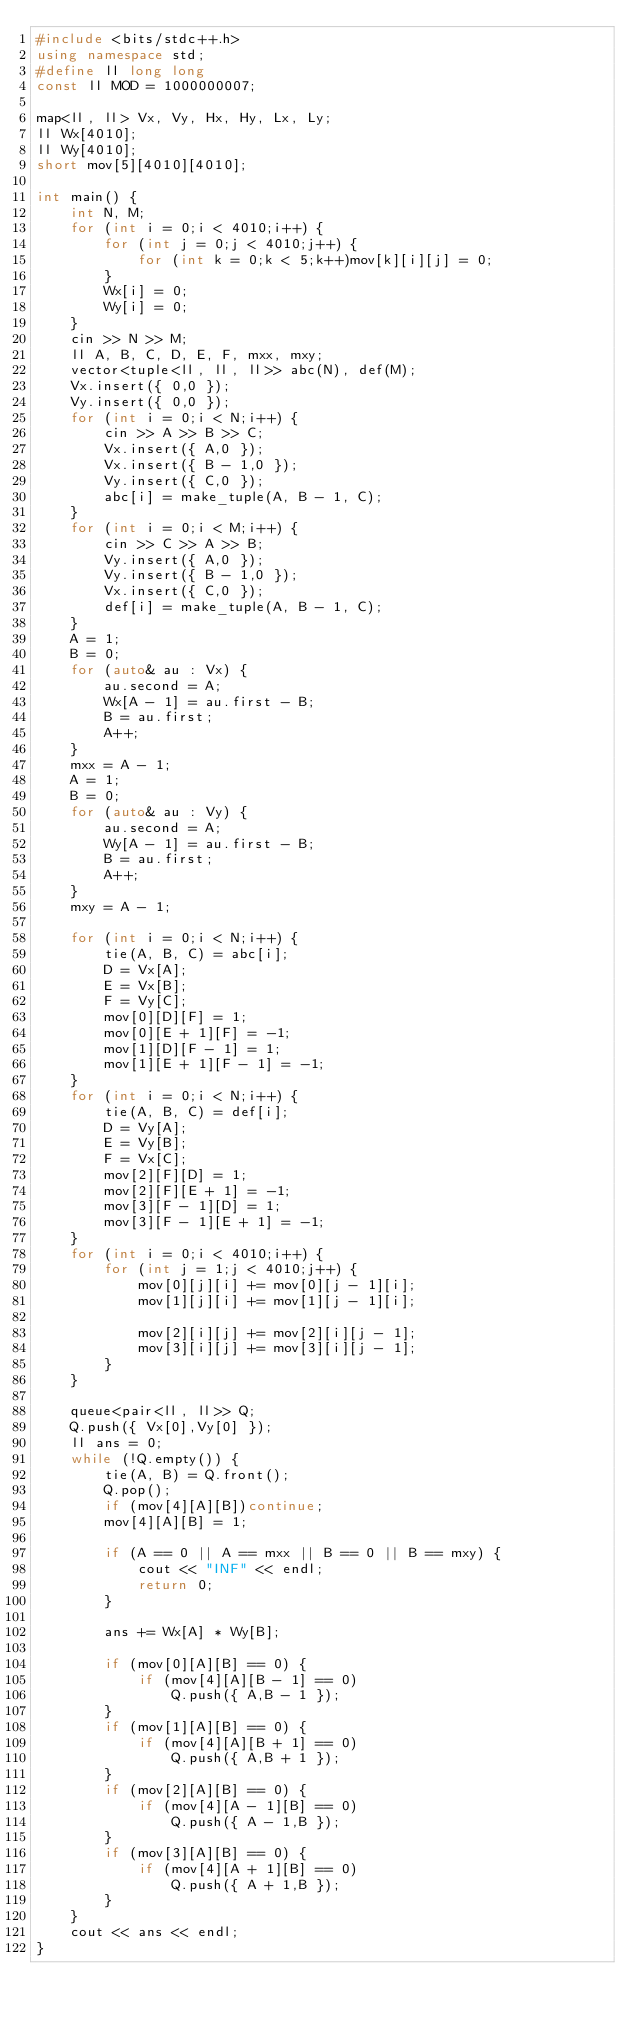Convert code to text. <code><loc_0><loc_0><loc_500><loc_500><_C++_>#include <bits/stdc++.h>
using namespace std;
#define ll long long
const ll MOD = 1000000007;

map<ll, ll> Vx, Vy, Hx, Hy, Lx, Ly;
ll Wx[4010];
ll Wy[4010];
short mov[5][4010][4010];

int main() {
	int N, M;
	for (int i = 0;i < 4010;i++) {
		for (int j = 0;j < 4010;j++) {
			for (int k = 0;k < 5;k++)mov[k][i][j] = 0;
		}
		Wx[i] = 0;
		Wy[i] = 0;
	}
	cin >> N >> M;
	ll A, B, C, D, E, F, mxx, mxy;
	vector<tuple<ll, ll, ll>> abc(N), def(M);
	Vx.insert({ 0,0 });
	Vy.insert({ 0,0 });
	for (int i = 0;i < N;i++) {
		cin >> A >> B >> C;
		Vx.insert({ A,0 });
		Vx.insert({ B - 1,0 });
		Vy.insert({ C,0 });
		abc[i] = make_tuple(A, B - 1, C);
	}
	for (int i = 0;i < M;i++) {
		cin >> C >> A >> B;
		Vy.insert({ A,0 });
		Vy.insert({ B - 1,0 });
		Vx.insert({ C,0 });
		def[i] = make_tuple(A, B - 1, C);
	}
	A = 1;
	B = 0;
	for (auto& au : Vx) {
		au.second = A;
		Wx[A - 1] = au.first - B;
		B = au.first;
		A++;
	}
	mxx = A - 1;
	A = 1;
	B = 0;
	for (auto& au : Vy) {
		au.second = A;
		Wy[A - 1] = au.first - B;
		B = au.first;
		A++;
	}
	mxy = A - 1;

	for (int i = 0;i < N;i++) {
		tie(A, B, C) = abc[i];
		D = Vx[A];
		E = Vx[B];
		F = Vy[C];
		mov[0][D][F] = 1;
		mov[0][E + 1][F] = -1;
		mov[1][D][F - 1] = 1;
		mov[1][E + 1][F - 1] = -1;
	}
	for (int i = 0;i < N;i++) {
		tie(A, B, C) = def[i];
		D = Vy[A];
		E = Vy[B];
		F = Vx[C];
		mov[2][F][D] = 1;
		mov[2][F][E + 1] = -1;
		mov[3][F - 1][D] = 1;
		mov[3][F - 1][E + 1] = -1;
	}
	for (int i = 0;i < 4010;i++) {
		for (int j = 1;j < 4010;j++) {
			mov[0][j][i] += mov[0][j - 1][i];
			mov[1][j][i] += mov[1][j - 1][i];

			mov[2][i][j] += mov[2][i][j - 1];
			mov[3][i][j] += mov[3][i][j - 1];
		}
	}

	queue<pair<ll, ll>> Q;
	Q.push({ Vx[0],Vy[0] });
	ll ans = 0;
	while (!Q.empty()) {
		tie(A, B) = Q.front();
		Q.pop();
		if (mov[4][A][B])continue;
		mov[4][A][B] = 1;

		if (A == 0 || A == mxx || B == 0 || B == mxy) {
			cout << "INF" << endl;
			return 0;
		}

		ans += Wx[A] * Wy[B];

		if (mov[0][A][B] == 0) {
			if (mov[4][A][B - 1] == 0)
				Q.push({ A,B - 1 });
		}
		if (mov[1][A][B] == 0) {
			if (mov[4][A][B + 1] == 0)
				Q.push({ A,B + 1 });
		}
		if (mov[2][A][B] == 0) {
			if (mov[4][A - 1][B] == 0)
				Q.push({ A - 1,B });
		}
		if (mov[3][A][B] == 0) {
			if (mov[4][A + 1][B] == 0)
				Q.push({ A + 1,B });
		}
	}
	cout << ans << endl;
}</code> 